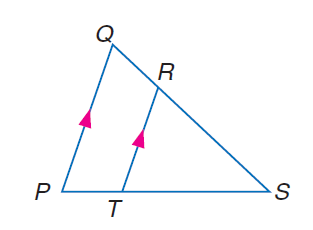Answer the mathemtical geometry problem and directly provide the correct option letter.
Question: If R T = 15, Q P = 21, and P T = 8, find T S.
Choices: A: 8 B: 15 C: 20 D: 21 C 